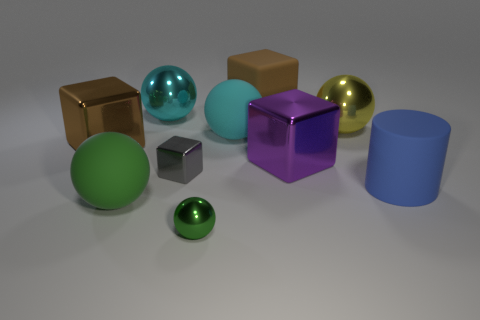Subtract all yellow balls. How many balls are left? 4 Subtract all yellow balls. How many balls are left? 4 Subtract all red balls. Subtract all brown blocks. How many balls are left? 5 Subtract all cylinders. How many objects are left? 9 Add 5 yellow things. How many yellow things are left? 6 Add 2 large blue matte things. How many large blue matte things exist? 3 Subtract 0 blue blocks. How many objects are left? 10 Subtract all large matte balls. Subtract all blue matte blocks. How many objects are left? 8 